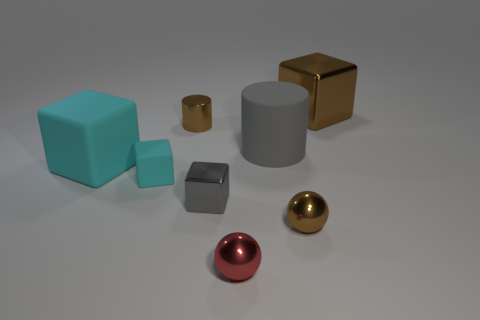Subtract all large metallic cubes. How many cubes are left? 3 Add 1 tiny blue metal things. How many objects exist? 9 Subtract all green cylinders. How many cyan cubes are left? 2 Subtract all brown cylinders. How many cylinders are left? 1 Subtract all spheres. How many objects are left? 6 Add 5 big red things. How many big red things exist? 5 Subtract 0 purple cubes. How many objects are left? 8 Subtract 1 balls. How many balls are left? 1 Subtract all yellow blocks. Subtract all blue cylinders. How many blocks are left? 4 Subtract all big gray matte cylinders. Subtract all blocks. How many objects are left? 3 